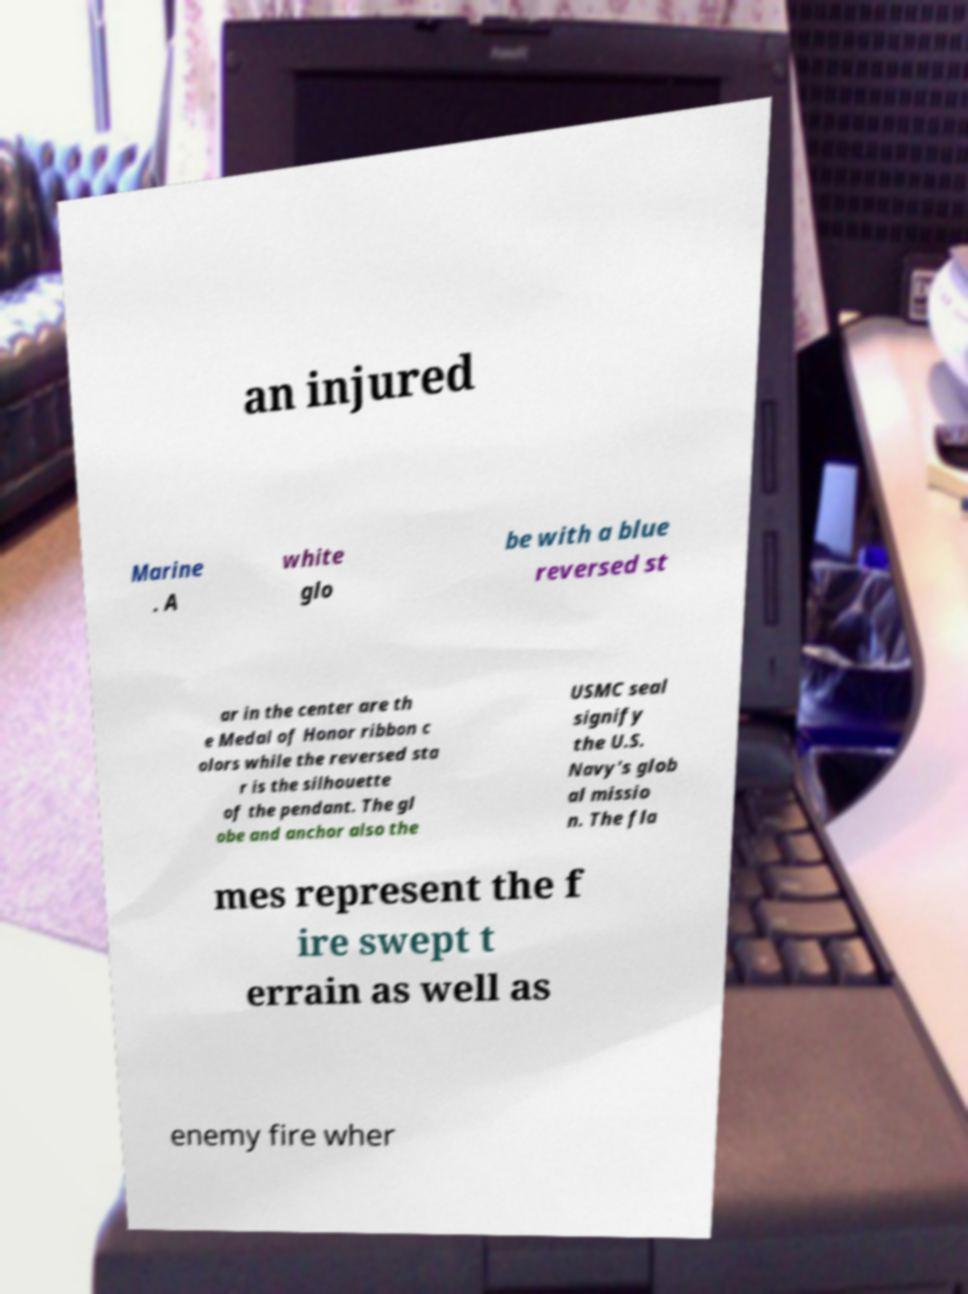Could you assist in decoding the text presented in this image and type it out clearly? an injured Marine . A white glo be with a blue reversed st ar in the center are th e Medal of Honor ribbon c olors while the reversed sta r is the silhouette of the pendant. The gl obe and anchor also the USMC seal signify the U.S. Navy's glob al missio n. The fla mes represent the f ire swept t errain as well as enemy fire wher 